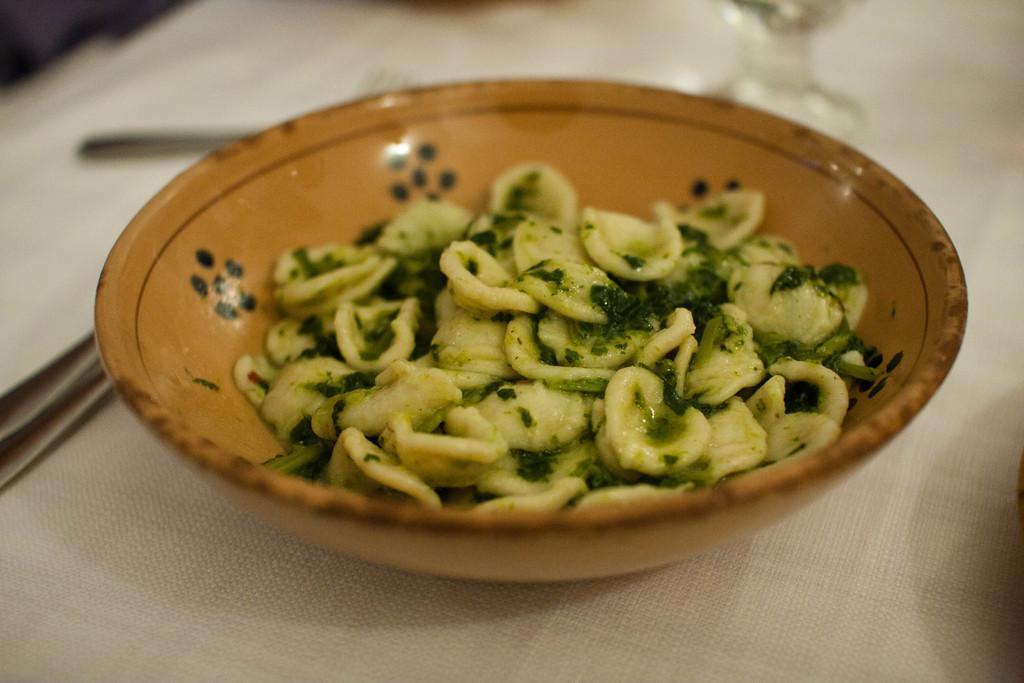Could you give a brief overview of what you see in this image? In this picture we can see a bowl, there is some food in this bowl, we can see a blurry background, it looks like a cloth at the bottom. 